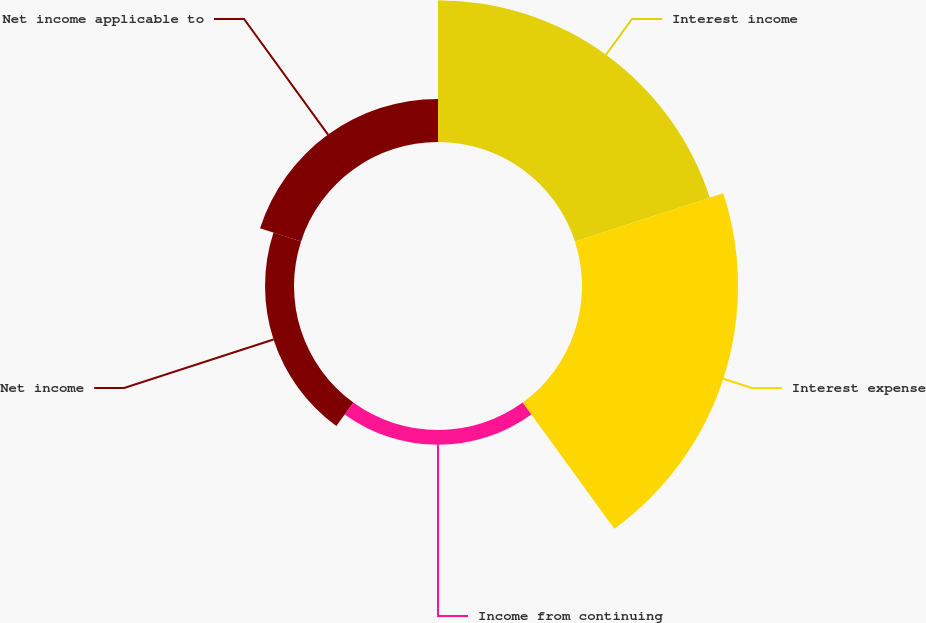Convert chart. <chart><loc_0><loc_0><loc_500><loc_500><pie_chart><fcel>Interest income<fcel>Interest expense<fcel>Income from continuing<fcel>Net income<fcel>Net income applicable to<nl><fcel>36.87%<fcel>40.56%<fcel>3.84%<fcel>7.53%<fcel>11.21%<nl></chart> 